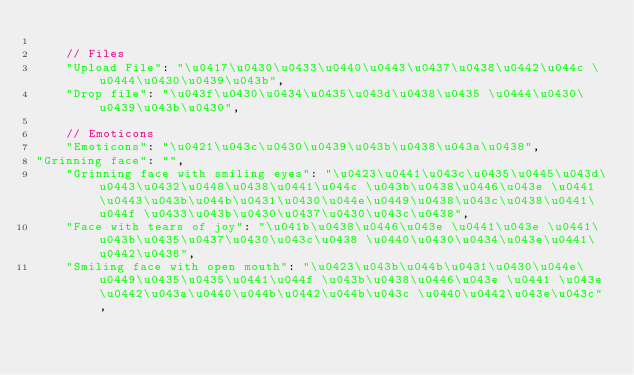Convert code to text. <code><loc_0><loc_0><loc_500><loc_500><_JavaScript_>
    // Files
    "Upload File": "\u0417\u0430\u0433\u0440\u0443\u0437\u0438\u0442\u044c \u0444\u0430\u0439\u043b",
    "Drop file": "\u043f\u0430\u0434\u0435\u043d\u0438\u0435 \u0444\u0430\u0439\u043b\u0430",

    // Emoticons
    "Emoticons": "\u0421\u043c\u0430\u0439\u043b\u0438\u043a\u0438",
"Grinning face": "",
    "Grinning face with smiling eyes": "\u0423\u0441\u043c\u0435\u0445\u043d\u0443\u0432\u0448\u0438\u0441\u044c \u043b\u0438\u0446\u043e \u0441 \u0443\u043b\u044b\u0431\u0430\u044e\u0449\u0438\u043c\u0438\u0441\u044f \u0433\u043b\u0430\u0437\u0430\u043c\u0438",
    "Face with tears of joy": "\u041b\u0438\u0446\u043e \u0441\u043e \u0441\u043b\u0435\u0437\u0430\u043c\u0438 \u0440\u0430\u0434\u043e\u0441\u0442\u0438",
    "Smiling face with open mouth": "\u0423\u043b\u044b\u0431\u0430\u044e\u0449\u0435\u0435\u0441\u044f \u043b\u0438\u0446\u043e \u0441 \u043e\u0442\u043a\u0440\u044b\u0442\u044b\u043c \u0440\u0442\u043e\u043c",</code> 